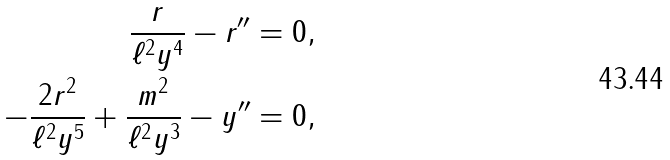Convert formula to latex. <formula><loc_0><loc_0><loc_500><loc_500>\frac { r } { \ell ^ { 2 } y ^ { 4 } } - r ^ { \prime \prime } & = 0 , \\ - \frac { 2 r ^ { 2 } } { \ell ^ { 2 } y ^ { 5 } } + \frac { m ^ { 2 } } { \ell ^ { 2 } y ^ { 3 } } - y ^ { \prime \prime } & = 0 ,</formula> 